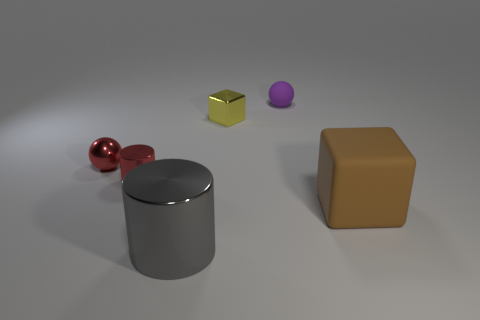Add 3 tiny yellow shiny cubes. How many objects exist? 9 Subtract all cylinders. How many objects are left? 4 Subtract all blue cylinders. How many green blocks are left? 0 Subtract all small red metallic spheres. Subtract all tiny yellow metallic things. How many objects are left? 4 Add 3 large metal cylinders. How many large metal cylinders are left? 4 Add 5 small metal blocks. How many small metal blocks exist? 6 Subtract 1 purple spheres. How many objects are left? 5 Subtract 1 cylinders. How many cylinders are left? 1 Subtract all blue cubes. Subtract all gray balls. How many cubes are left? 2 